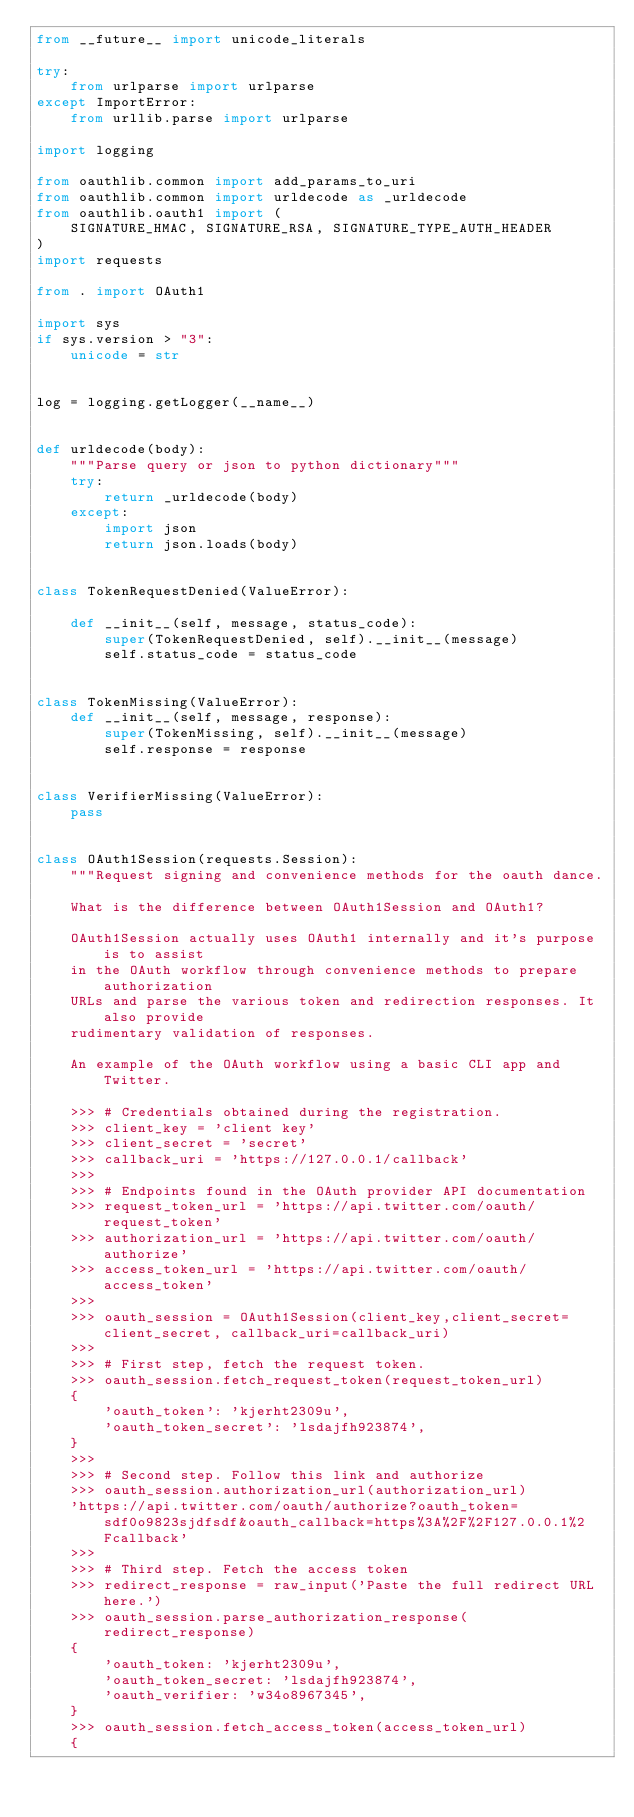<code> <loc_0><loc_0><loc_500><loc_500><_Python_>from __future__ import unicode_literals

try:
    from urlparse import urlparse
except ImportError:
    from urllib.parse import urlparse

import logging

from oauthlib.common import add_params_to_uri
from oauthlib.common import urldecode as _urldecode
from oauthlib.oauth1 import (
    SIGNATURE_HMAC, SIGNATURE_RSA, SIGNATURE_TYPE_AUTH_HEADER
)
import requests

from . import OAuth1

import sys
if sys.version > "3":
    unicode = str


log = logging.getLogger(__name__)


def urldecode(body):
    """Parse query or json to python dictionary"""
    try:
        return _urldecode(body)
    except:
        import json
        return json.loads(body)


class TokenRequestDenied(ValueError):

    def __init__(self, message, status_code):
        super(TokenRequestDenied, self).__init__(message)
        self.status_code = status_code


class TokenMissing(ValueError):
    def __init__(self, message, response):
        super(TokenMissing, self).__init__(message)
        self.response = response


class VerifierMissing(ValueError):
    pass


class OAuth1Session(requests.Session):
    """Request signing and convenience methods for the oauth dance.

    What is the difference between OAuth1Session and OAuth1?

    OAuth1Session actually uses OAuth1 internally and it's purpose is to assist
    in the OAuth workflow through convenience methods to prepare authorization
    URLs and parse the various token and redirection responses. It also provide
    rudimentary validation of responses.

    An example of the OAuth workflow using a basic CLI app and Twitter.

    >>> # Credentials obtained during the registration.
    >>> client_key = 'client key'
    >>> client_secret = 'secret'
    >>> callback_uri = 'https://127.0.0.1/callback'
    >>>
    >>> # Endpoints found in the OAuth provider API documentation
    >>> request_token_url = 'https://api.twitter.com/oauth/request_token'
    >>> authorization_url = 'https://api.twitter.com/oauth/authorize'
    >>> access_token_url = 'https://api.twitter.com/oauth/access_token'
    >>>
    >>> oauth_session = OAuth1Session(client_key,client_secret=client_secret, callback_uri=callback_uri)
    >>>
    >>> # First step, fetch the request token.
    >>> oauth_session.fetch_request_token(request_token_url)
    {
        'oauth_token': 'kjerht2309u',
        'oauth_token_secret': 'lsdajfh923874',
    }
    >>>
    >>> # Second step. Follow this link and authorize
    >>> oauth_session.authorization_url(authorization_url)
    'https://api.twitter.com/oauth/authorize?oauth_token=sdf0o9823sjdfsdf&oauth_callback=https%3A%2F%2F127.0.0.1%2Fcallback'
    >>>
    >>> # Third step. Fetch the access token
    >>> redirect_response = raw_input('Paste the full redirect URL here.')
    >>> oauth_session.parse_authorization_response(redirect_response)
    {
        'oauth_token: 'kjerht2309u',
        'oauth_token_secret: 'lsdajfh923874',
        'oauth_verifier: 'w34o8967345',
    }
    >>> oauth_session.fetch_access_token(access_token_url)
    {</code> 